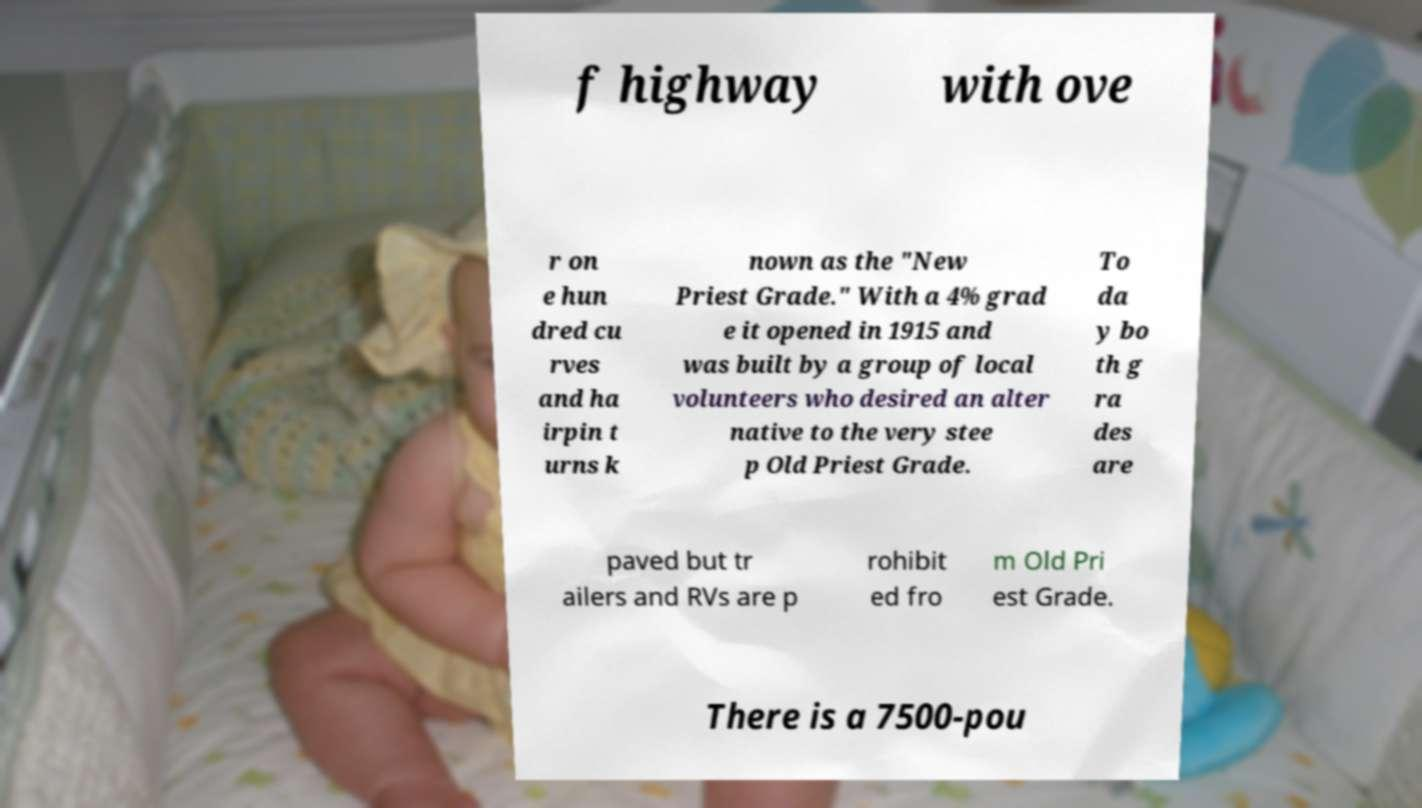Could you assist in decoding the text presented in this image and type it out clearly? f highway with ove r on e hun dred cu rves and ha irpin t urns k nown as the "New Priest Grade." With a 4% grad e it opened in 1915 and was built by a group of local volunteers who desired an alter native to the very stee p Old Priest Grade. To da y bo th g ra des are paved but tr ailers and RVs are p rohibit ed fro m Old Pri est Grade. There is a 7500-pou 